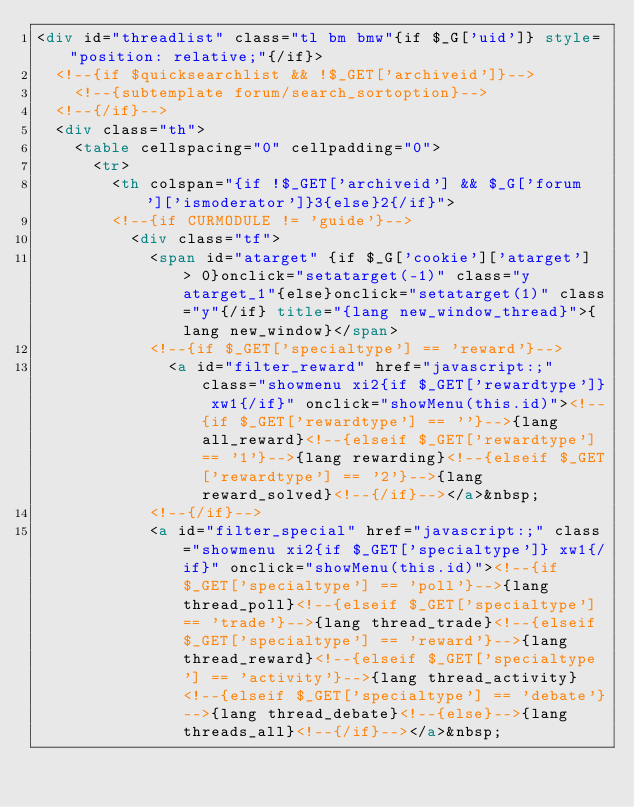<code> <loc_0><loc_0><loc_500><loc_500><_HTML_><div id="threadlist" class="tl bm bmw"{if $_G['uid']} style="position: relative;"{/if}>
	<!--{if $quicksearchlist && !$_GET['archiveid']}-->
		<!--{subtemplate forum/search_sortoption}-->
	<!--{/if}-->
	<div class="th">
		<table cellspacing="0" cellpadding="0">
			<tr>
				<th colspan="{if !$_GET['archiveid'] && $_G['forum']['ismoderator']}3{else}2{/if}">
				<!--{if CURMODULE != 'guide'}-->
					<div class="tf">
						<span id="atarget" {if $_G['cookie']['atarget'] > 0}onclick="setatarget(-1)" class="y atarget_1"{else}onclick="setatarget(1)" class="y"{/if} title="{lang new_window_thread}">{lang new_window}</span>
						<!--{if $_GET['specialtype'] == 'reward'}-->
							<a id="filter_reward" href="javascript:;" class="showmenu xi2{if $_GET['rewardtype']} xw1{/if}" onclick="showMenu(this.id)"><!--{if $_GET['rewardtype'] == ''}-->{lang all_reward}<!--{elseif $_GET['rewardtype'] == '1'}-->{lang rewarding}<!--{elseif $_GET['rewardtype'] == '2'}-->{lang reward_solved}<!--{/if}--></a>&nbsp;
						<!--{/if}-->
						<a id="filter_special" href="javascript:;" class="showmenu xi2{if $_GET['specialtype']} xw1{/if}" onclick="showMenu(this.id)"><!--{if $_GET['specialtype'] == 'poll'}-->{lang thread_poll}<!--{elseif $_GET['specialtype'] == 'trade'}-->{lang thread_trade}<!--{elseif $_GET['specialtype'] == 'reward'}-->{lang thread_reward}<!--{elseif $_GET['specialtype'] == 'activity'}-->{lang thread_activity}<!--{elseif $_GET['specialtype'] == 'debate'}-->{lang thread_debate}<!--{else}-->{lang threads_all}<!--{/if}--></a>&nbsp;						</code> 